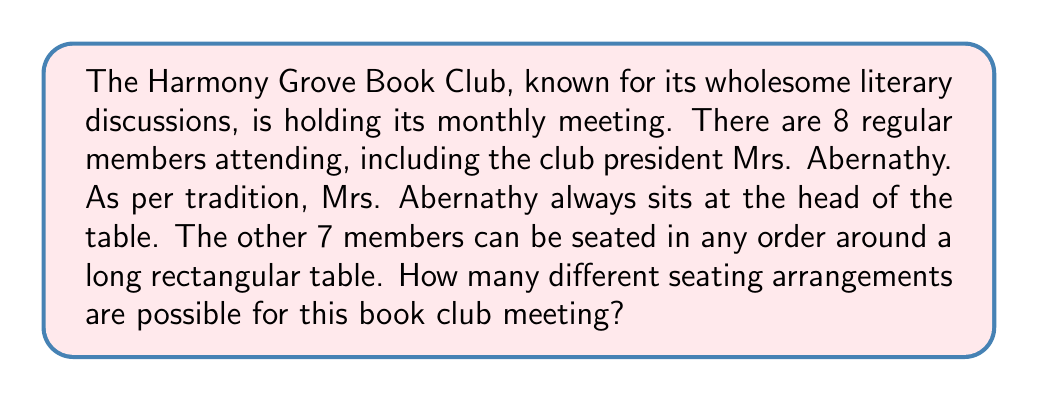Provide a solution to this math problem. Let's approach this step-by-step:

1) First, we need to recognize that this is a permutation problem. We are arranging 7 people in a specific order.

2) Mrs. Abernathy's position is fixed at the head of the table, so we don't need to consider her in our calculation.

3) For the remaining 7 members, we need to calculate how many ways we can arrange them in the 7 available seats.

4) This is a straightforward permutation of 7 people in 7 seats. The formula for this is:

   $$P(7,7) = 7!$$

5) Let's calculate this:
   
   $$7! = 7 \times 6 \times 5 \times 4 \times 3 \times 2 \times 1 = 5040$$

6) Therefore, there are 5040 possible seating arrangements for the 7 members (excluding Mrs. Abernathy).

This calculation ensures that every possible order of the 7 members is accounted for, while maintaining the decorum of having the club president in her traditional seat.
Answer: $5040$ seating arrangements 